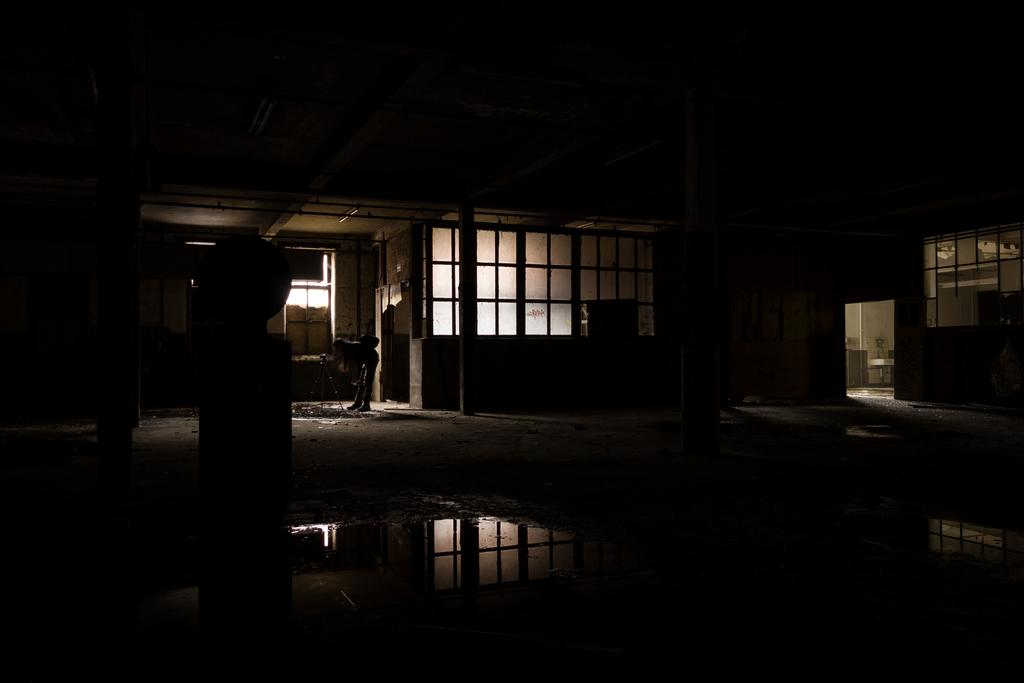What type of material is used for the windows in the image? The windows in the image are made of glass. Can you describe the person in the image? There is a person in the image, but no specific details about their appearance or actions are provided. What is the camera stand used for in the image? The camera stand is likely used for supporting a camera during photography or filming. What is the structure of the building in the image? The building in the image has a roof and pillars. What is visible outside the building in the image? Water is visible outside the building in the image. How many balls are visible in the image? There are no balls present in the image. What type of clouds can be seen in the image? There is no mention of clouds in the image; it only mentions glass windows, a person, a camera stand, a roof, pillars, and water. 